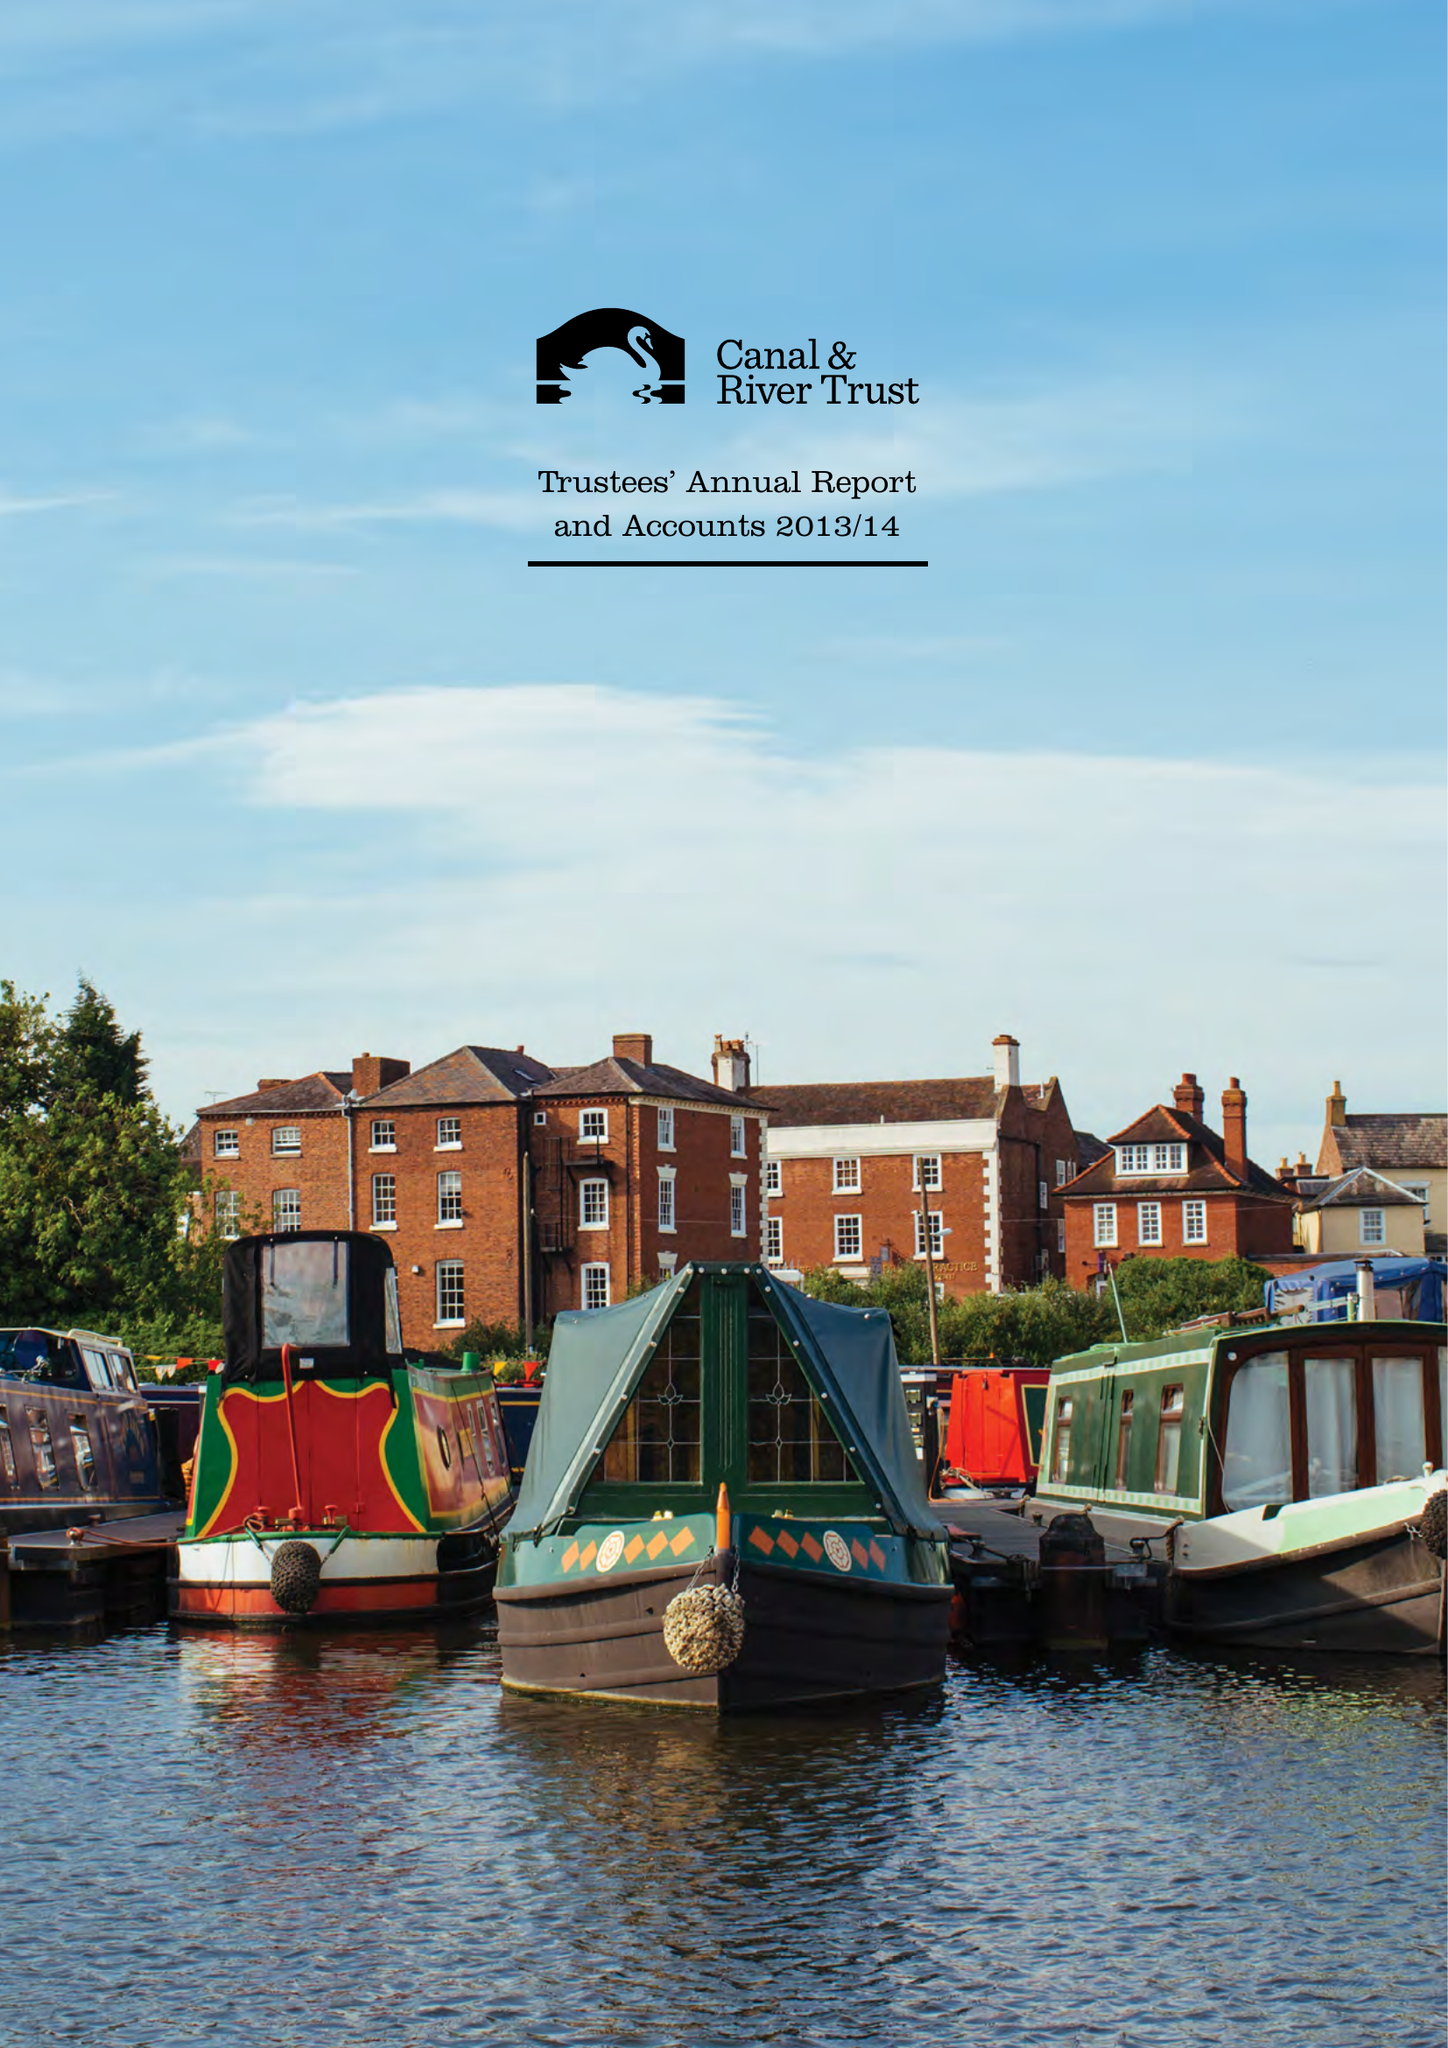What is the value for the address__street_line?
Answer the question using a single word or phrase. 500 ELDER GATE 